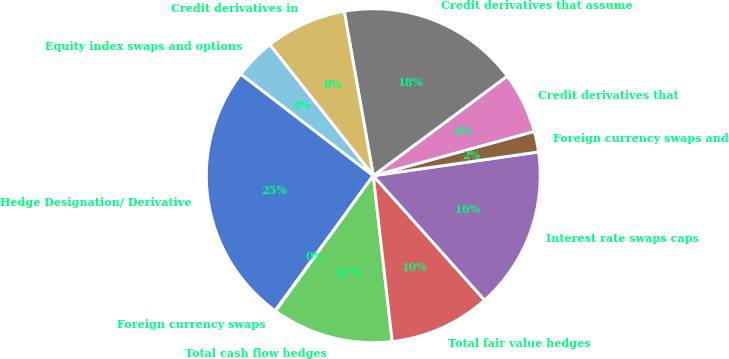Convert chart. <chart><loc_0><loc_0><loc_500><loc_500><pie_chart><fcel>Hedge Designation/ Derivative<fcel>Foreign currency swaps<fcel>Total cash flow hedges<fcel>Total fair value hedges<fcel>Interest rate swaps caps<fcel>Foreign currency swaps and<fcel>Credit derivatives that<fcel>Credit derivatives that assume<fcel>Credit derivatives in<fcel>Equity index swaps and options<nl><fcel>25.41%<fcel>0.05%<fcel>11.76%<fcel>9.8%<fcel>15.66%<fcel>2.0%<fcel>5.9%<fcel>17.61%<fcel>7.85%<fcel>3.95%<nl></chart> 